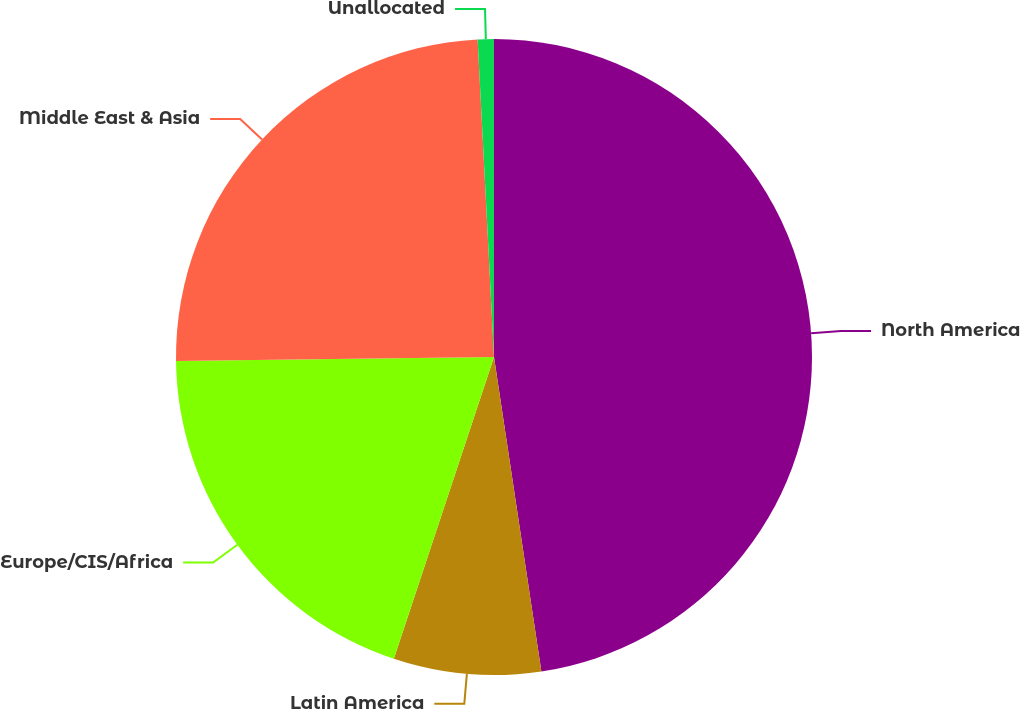<chart> <loc_0><loc_0><loc_500><loc_500><pie_chart><fcel>North America<fcel>Latin America<fcel>Europe/CIS/Africa<fcel>Middle East & Asia<fcel>Unallocated<nl><fcel>47.62%<fcel>7.48%<fcel>19.7%<fcel>24.38%<fcel>0.82%<nl></chart> 